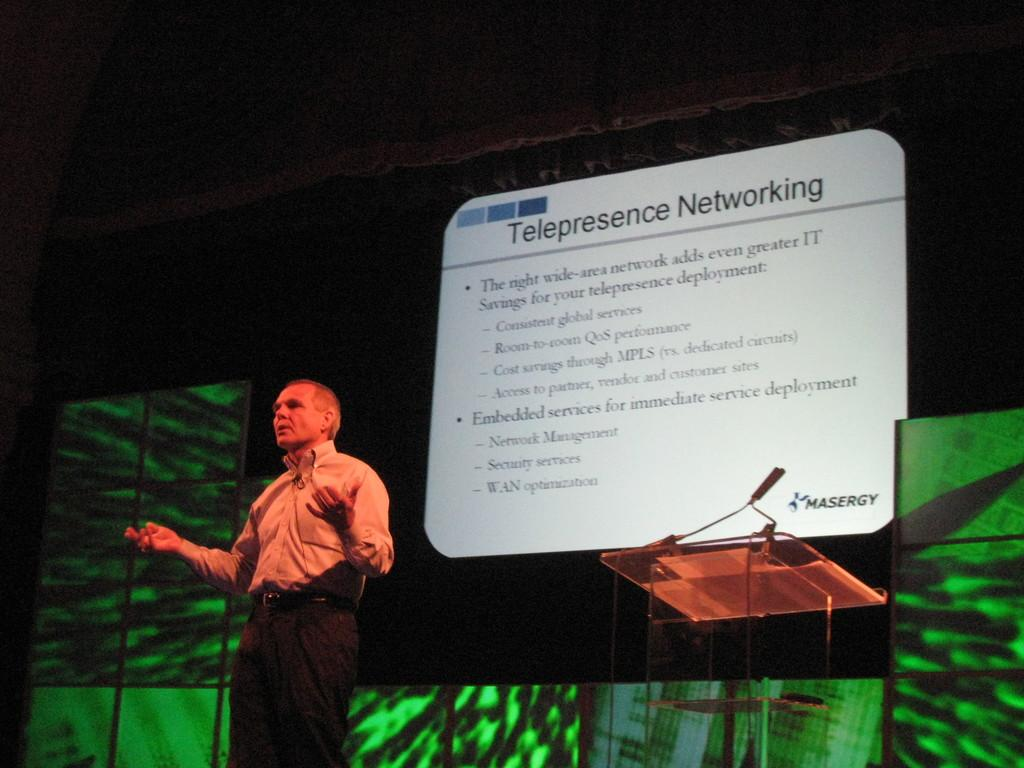What is the main subject of the image? There is a man standing in the image. Where is the man standing? The man is standing on the floor. What can be seen in the background of the image? There is a display screen and a podium in the background of the image. Can you see an arch near the seashore in the image? There is no arch or seashore present in the image. What type of spade is the man holding in the image? The man is not holding any spade in the image. 